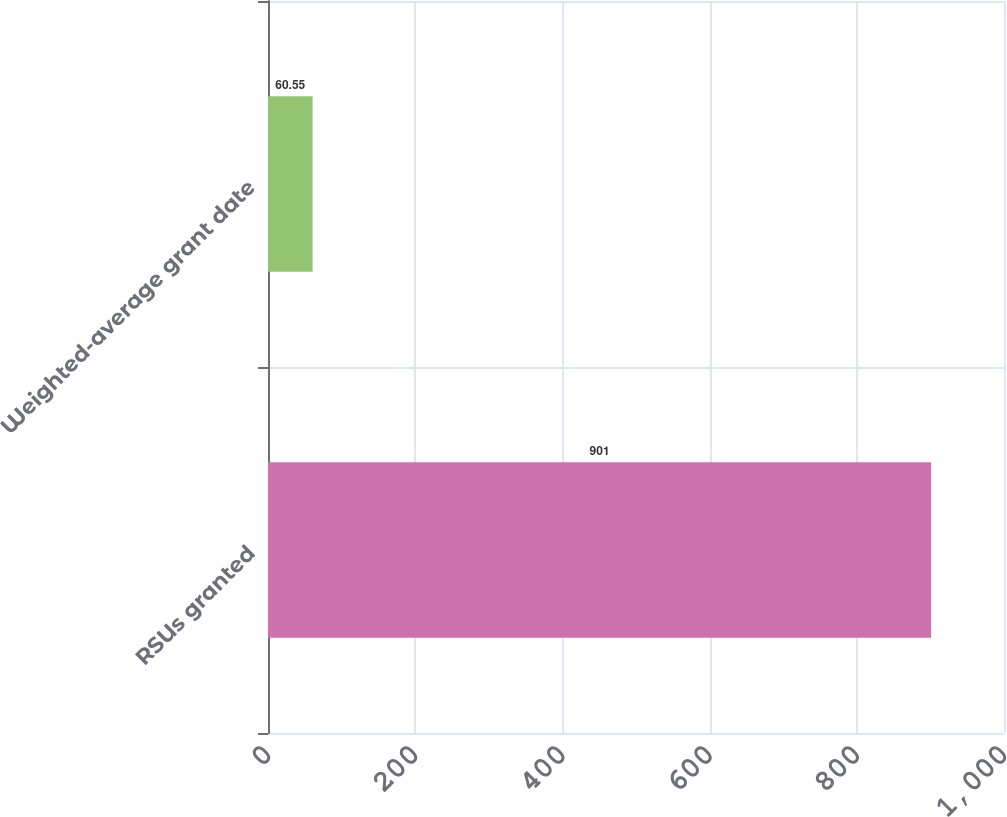Convert chart. <chart><loc_0><loc_0><loc_500><loc_500><bar_chart><fcel>RSUs granted<fcel>Weighted-average grant date<nl><fcel>901<fcel>60.55<nl></chart> 